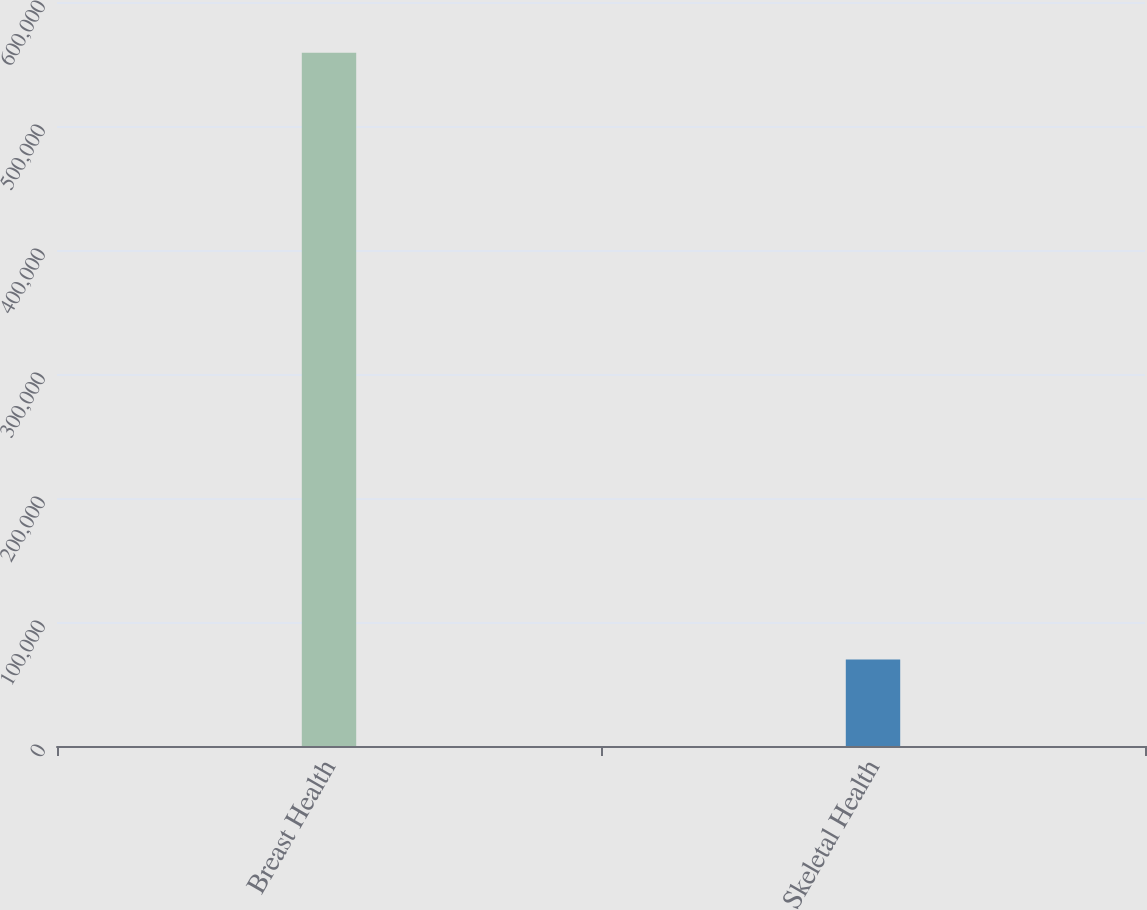Convert chart. <chart><loc_0><loc_0><loc_500><loc_500><bar_chart><fcel>Breast Health<fcel>Skeletal Health<nl><fcel>559092<fcel>69762<nl></chart> 